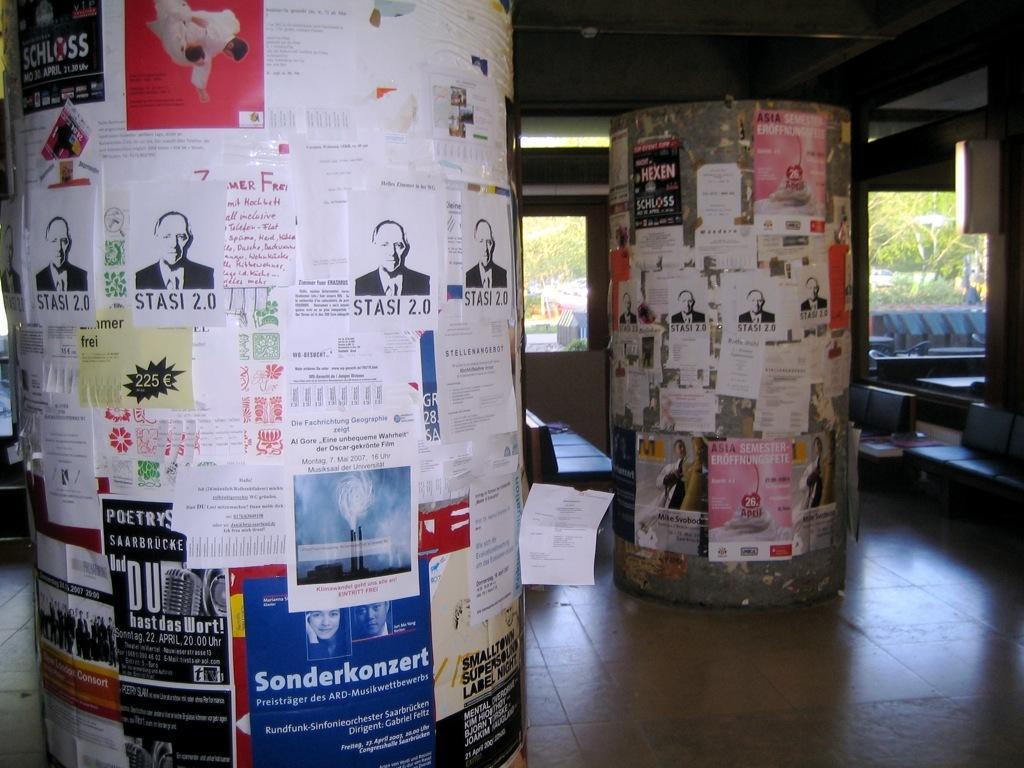In one or two sentences, can you explain what this image depicts? In this picture I can see there are two pillars and there are a few posters pasted on the pillars and there are a few chairs and there is a window in the backdrop and there are trees visible from the window. 